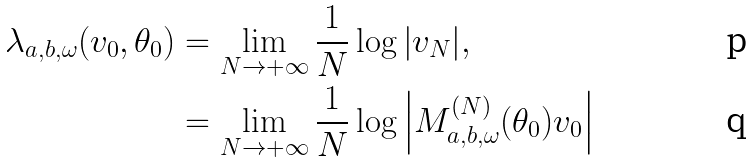Convert formula to latex. <formula><loc_0><loc_0><loc_500><loc_500>\lambda _ { a , b , \omega } ( v _ { 0 } , \theta _ { 0 } ) & = \lim _ { N \to + \infty } \frac { 1 } { N } \log { \left | v _ { N } \right | } , \\ & = \lim _ { N \to + \infty } \frac { 1 } { N } \log { \left | M _ { a , b , \omega } ^ { ( N ) } ( \theta _ { 0 } ) v _ { 0 } \right | }</formula> 